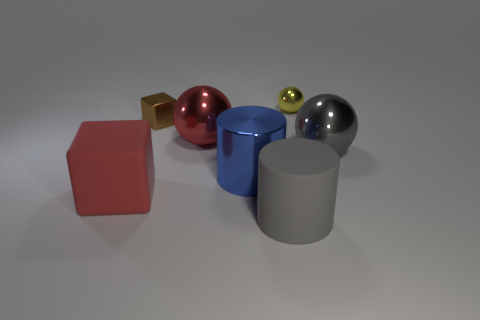What is the shape of the big shiny object that is the same color as the matte block?
Ensure brevity in your answer.  Sphere. Is there a big gray object that is in front of the large object on the left side of the small block to the left of the tiny ball?
Give a very brief answer. Yes. Do the red rubber object and the brown shiny cube have the same size?
Give a very brief answer. No. Are there an equal number of large blue shiny cylinders behind the blue metallic thing and gray cylinders to the left of the red shiny ball?
Provide a short and direct response. Yes. What shape is the red object to the left of the red shiny object?
Offer a terse response. Cube. What is the shape of the yellow object that is the same size as the brown metal thing?
Keep it short and to the point. Sphere. There is a big ball to the left of the metal object that is behind the tiny object that is in front of the small sphere; what color is it?
Ensure brevity in your answer.  Red. Is the gray matte object the same shape as the big blue thing?
Provide a succinct answer. Yes. Are there an equal number of gray objects that are on the left side of the matte cube and blue rubber objects?
Your answer should be very brief. Yes. What number of other objects are the same material as the small block?
Provide a short and direct response. 4. 